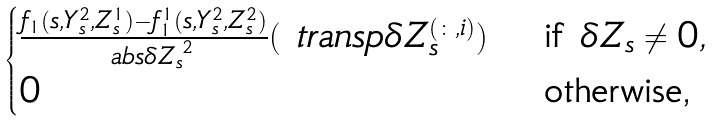<formula> <loc_0><loc_0><loc_500><loc_500>\begin{cases} \frac { f _ { 1 } ( s , Y ^ { 2 } _ { s } , Z ^ { 1 } _ { s } ) - f ^ { 1 } _ { 1 } ( s , Y ^ { 2 } _ { s } , Z ^ { 2 } _ { s } ) } { \ a b s { \delta Z _ { s } } ^ { 2 } } ( \ t r a n s p \delta Z _ { s } ^ { ( \colon , i ) } ) & \text { if } \delta Z _ { s } \neq 0 , \\ 0 & \text { otherwise,} \end{cases}</formula> 